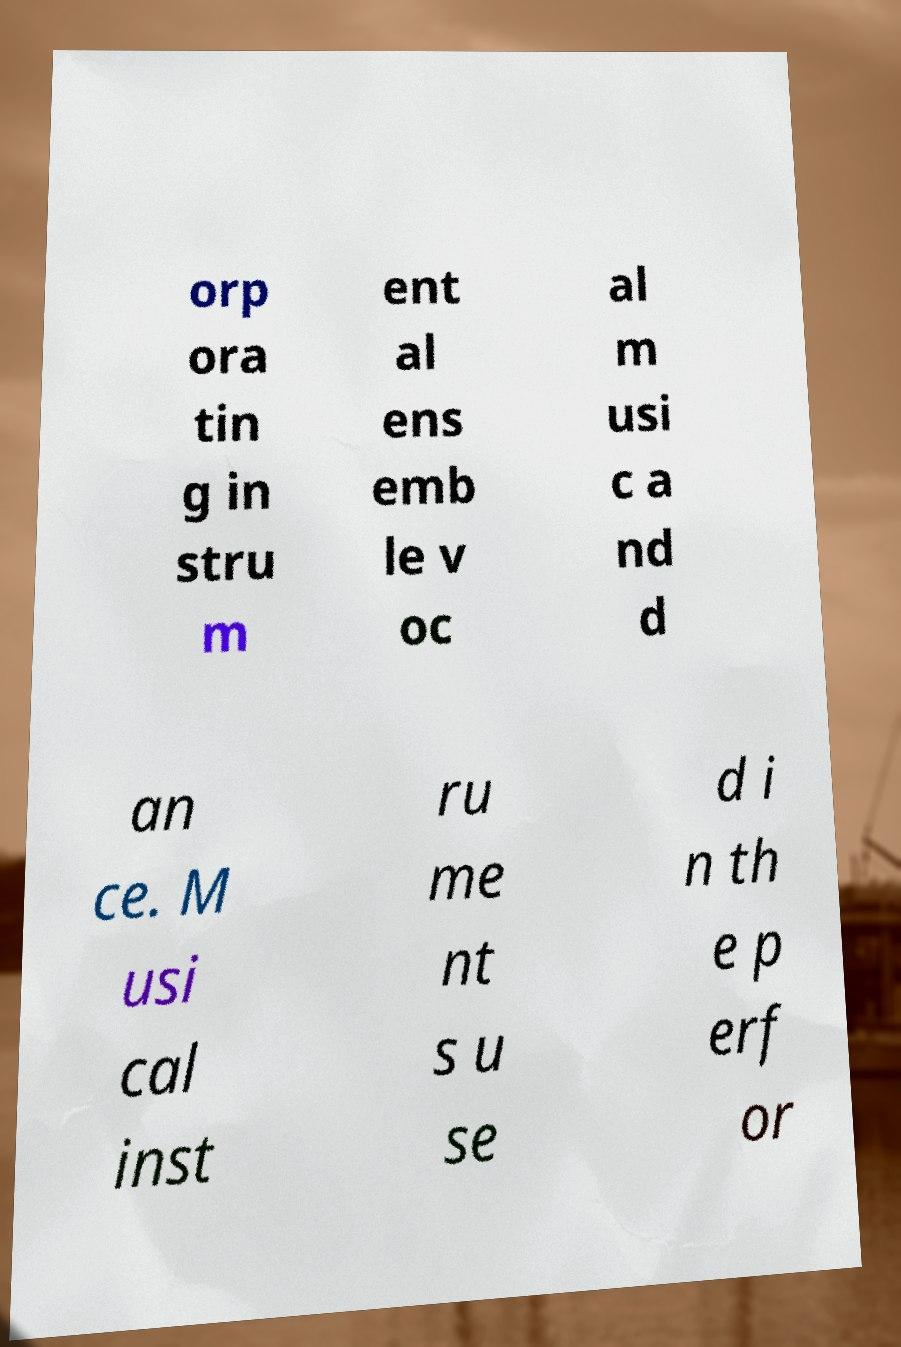Could you extract and type out the text from this image? orp ora tin g in stru m ent al ens emb le v oc al m usi c a nd d an ce. M usi cal inst ru me nt s u se d i n th e p erf or 